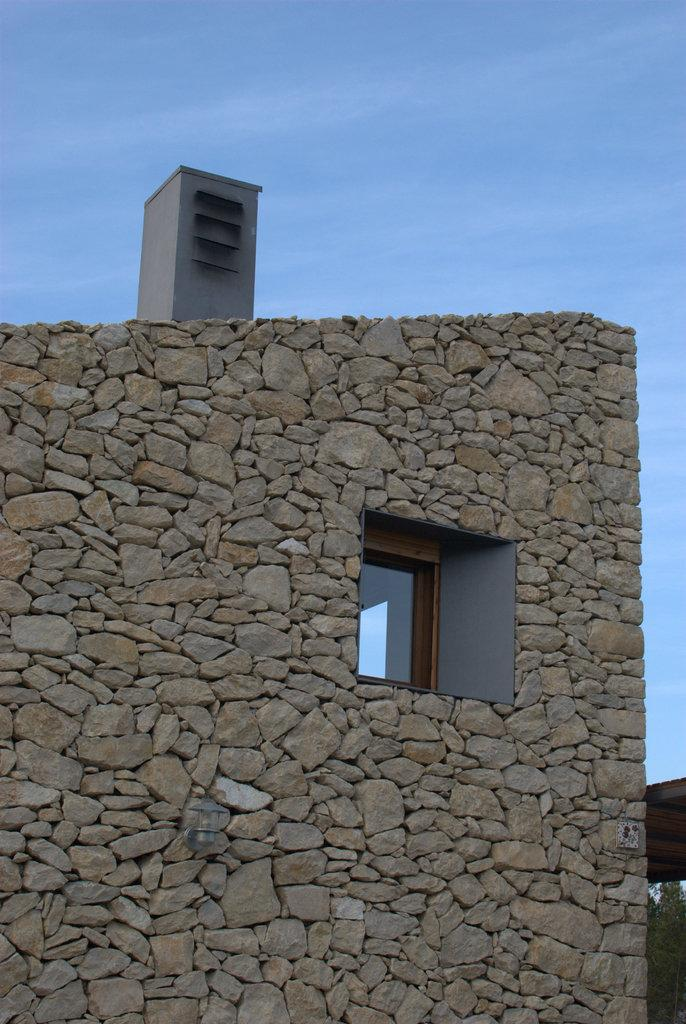What type of structure can be seen in the image? There is a wall in the image. Is there any opening in the wall? Yes, there is a window in the image. What can be seen outside the window? Trees are visible in the image. What else is present in the image besides the wall and window? There are objects in the image. What is visible in the background of the image? The sky is visible in the background of the image. Can you see a plough being used in the image? No, there is no plough present in the image. What type of cable can be seen connecting the objects in the image? There is no cable connecting the objects in the image. 